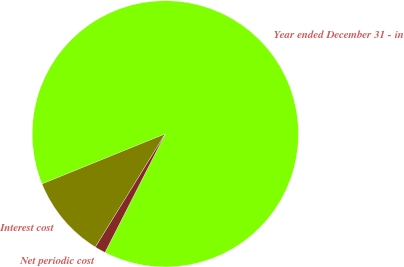<chart> <loc_0><loc_0><loc_500><loc_500><pie_chart><fcel>Year ended December 31 - in<fcel>Interest cost<fcel>Net periodic cost<nl><fcel>88.62%<fcel>10.05%<fcel>1.32%<nl></chart> 